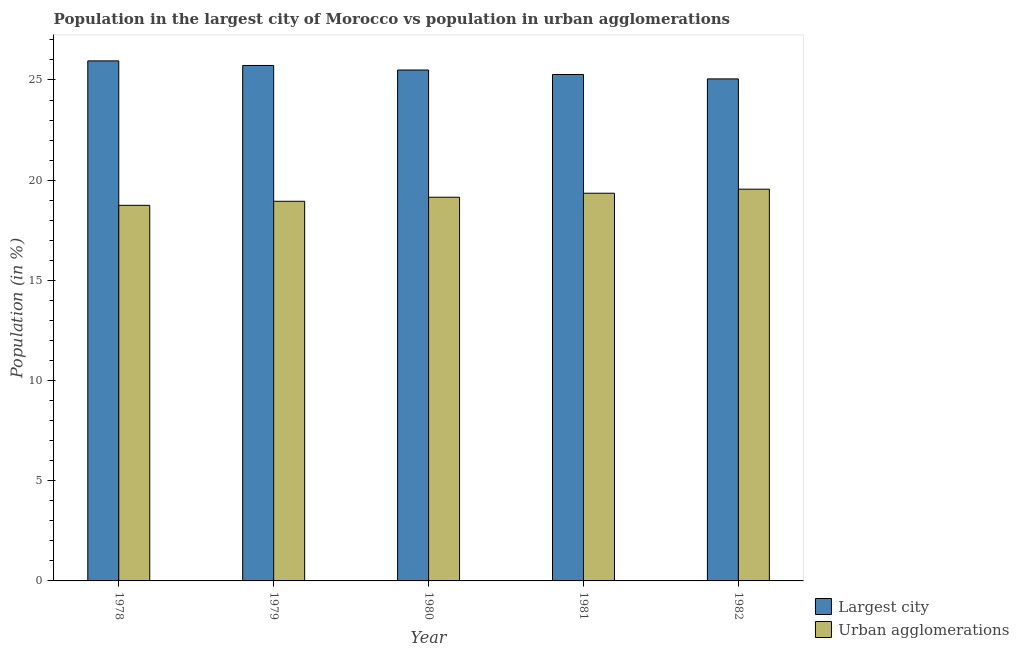How many different coloured bars are there?
Your response must be concise. 2. How many groups of bars are there?
Your response must be concise. 5. Are the number of bars per tick equal to the number of legend labels?
Your answer should be very brief. Yes. In how many cases, is the number of bars for a given year not equal to the number of legend labels?
Keep it short and to the point. 0. What is the population in urban agglomerations in 1980?
Keep it short and to the point. 19.15. Across all years, what is the maximum population in urban agglomerations?
Your answer should be very brief. 19.55. Across all years, what is the minimum population in the largest city?
Offer a terse response. 25.05. In which year was the population in the largest city maximum?
Offer a very short reply. 1978. In which year was the population in urban agglomerations minimum?
Offer a terse response. 1978. What is the total population in urban agglomerations in the graph?
Your answer should be compact. 95.74. What is the difference between the population in urban agglomerations in 1979 and that in 1982?
Your answer should be very brief. -0.6. What is the difference between the population in urban agglomerations in 1978 and the population in the largest city in 1980?
Your response must be concise. -0.4. What is the average population in the largest city per year?
Provide a short and direct response. 25.5. In how many years, is the population in the largest city greater than 17 %?
Keep it short and to the point. 5. What is the ratio of the population in urban agglomerations in 1979 to that in 1980?
Your response must be concise. 0.99. Is the difference between the population in the largest city in 1980 and 1981 greater than the difference between the population in urban agglomerations in 1980 and 1981?
Keep it short and to the point. No. What is the difference between the highest and the second highest population in urban agglomerations?
Your answer should be compact. 0.2. What is the difference between the highest and the lowest population in urban agglomerations?
Give a very brief answer. 0.81. Is the sum of the population in the largest city in 1978 and 1982 greater than the maximum population in urban agglomerations across all years?
Make the answer very short. Yes. What does the 2nd bar from the left in 1979 represents?
Make the answer very short. Urban agglomerations. What does the 2nd bar from the right in 1980 represents?
Provide a succinct answer. Largest city. How many bars are there?
Offer a very short reply. 10. Are all the bars in the graph horizontal?
Offer a terse response. No. How many years are there in the graph?
Give a very brief answer. 5. What is the difference between two consecutive major ticks on the Y-axis?
Provide a succinct answer. 5. Does the graph contain any zero values?
Offer a terse response. No. Does the graph contain grids?
Ensure brevity in your answer.  No. How are the legend labels stacked?
Keep it short and to the point. Vertical. What is the title of the graph?
Give a very brief answer. Population in the largest city of Morocco vs population in urban agglomerations. Does "Urban Population" appear as one of the legend labels in the graph?
Ensure brevity in your answer.  No. What is the label or title of the X-axis?
Your answer should be compact. Year. What is the label or title of the Y-axis?
Provide a short and direct response. Population (in %). What is the Population (in %) of Largest city in 1978?
Ensure brevity in your answer.  25.95. What is the Population (in %) of Urban agglomerations in 1978?
Offer a terse response. 18.74. What is the Population (in %) of Largest city in 1979?
Provide a short and direct response. 25.72. What is the Population (in %) in Urban agglomerations in 1979?
Your response must be concise. 18.95. What is the Population (in %) of Largest city in 1980?
Provide a short and direct response. 25.5. What is the Population (in %) in Urban agglomerations in 1980?
Give a very brief answer. 19.15. What is the Population (in %) of Largest city in 1981?
Your response must be concise. 25.27. What is the Population (in %) of Urban agglomerations in 1981?
Make the answer very short. 19.35. What is the Population (in %) in Largest city in 1982?
Ensure brevity in your answer.  25.05. What is the Population (in %) of Urban agglomerations in 1982?
Your answer should be compact. 19.55. Across all years, what is the maximum Population (in %) in Largest city?
Give a very brief answer. 25.95. Across all years, what is the maximum Population (in %) in Urban agglomerations?
Make the answer very short. 19.55. Across all years, what is the minimum Population (in %) of Largest city?
Provide a short and direct response. 25.05. Across all years, what is the minimum Population (in %) in Urban agglomerations?
Give a very brief answer. 18.74. What is the total Population (in %) in Largest city in the graph?
Your answer should be compact. 127.5. What is the total Population (in %) in Urban agglomerations in the graph?
Provide a succinct answer. 95.74. What is the difference between the Population (in %) in Largest city in 1978 and that in 1979?
Make the answer very short. 0.23. What is the difference between the Population (in %) of Urban agglomerations in 1978 and that in 1979?
Your response must be concise. -0.2. What is the difference between the Population (in %) in Largest city in 1978 and that in 1980?
Make the answer very short. 0.46. What is the difference between the Population (in %) in Urban agglomerations in 1978 and that in 1980?
Offer a very short reply. -0.4. What is the difference between the Population (in %) in Largest city in 1978 and that in 1981?
Your answer should be very brief. 0.68. What is the difference between the Population (in %) of Urban agglomerations in 1978 and that in 1981?
Your response must be concise. -0.6. What is the difference between the Population (in %) of Largest city in 1978 and that in 1982?
Provide a short and direct response. 0.9. What is the difference between the Population (in %) of Urban agglomerations in 1978 and that in 1982?
Make the answer very short. -0.81. What is the difference between the Population (in %) in Largest city in 1979 and that in 1980?
Your answer should be very brief. 0.23. What is the difference between the Population (in %) of Urban agglomerations in 1979 and that in 1980?
Keep it short and to the point. -0.2. What is the difference between the Population (in %) in Largest city in 1979 and that in 1981?
Make the answer very short. 0.45. What is the difference between the Population (in %) of Urban agglomerations in 1979 and that in 1981?
Ensure brevity in your answer.  -0.4. What is the difference between the Population (in %) in Largest city in 1979 and that in 1982?
Offer a terse response. 0.67. What is the difference between the Population (in %) of Urban agglomerations in 1979 and that in 1982?
Make the answer very short. -0.6. What is the difference between the Population (in %) of Largest city in 1980 and that in 1981?
Keep it short and to the point. 0.23. What is the difference between the Population (in %) of Urban agglomerations in 1980 and that in 1981?
Give a very brief answer. -0.2. What is the difference between the Population (in %) of Largest city in 1980 and that in 1982?
Make the answer very short. 0.44. What is the difference between the Population (in %) of Urban agglomerations in 1980 and that in 1982?
Keep it short and to the point. -0.4. What is the difference between the Population (in %) of Largest city in 1981 and that in 1982?
Offer a terse response. 0.22. What is the difference between the Population (in %) of Urban agglomerations in 1981 and that in 1982?
Keep it short and to the point. -0.2. What is the difference between the Population (in %) of Largest city in 1978 and the Population (in %) of Urban agglomerations in 1979?
Ensure brevity in your answer.  7.01. What is the difference between the Population (in %) of Largest city in 1978 and the Population (in %) of Urban agglomerations in 1980?
Your response must be concise. 6.8. What is the difference between the Population (in %) of Largest city in 1978 and the Population (in %) of Urban agglomerations in 1981?
Give a very brief answer. 6.6. What is the difference between the Population (in %) of Largest city in 1978 and the Population (in %) of Urban agglomerations in 1982?
Provide a short and direct response. 6.4. What is the difference between the Population (in %) of Largest city in 1979 and the Population (in %) of Urban agglomerations in 1980?
Your answer should be very brief. 6.58. What is the difference between the Population (in %) in Largest city in 1979 and the Population (in %) in Urban agglomerations in 1981?
Keep it short and to the point. 6.38. What is the difference between the Population (in %) in Largest city in 1979 and the Population (in %) in Urban agglomerations in 1982?
Offer a terse response. 6.17. What is the difference between the Population (in %) in Largest city in 1980 and the Population (in %) in Urban agglomerations in 1981?
Provide a short and direct response. 6.15. What is the difference between the Population (in %) of Largest city in 1980 and the Population (in %) of Urban agglomerations in 1982?
Give a very brief answer. 5.95. What is the difference between the Population (in %) of Largest city in 1981 and the Population (in %) of Urban agglomerations in 1982?
Provide a succinct answer. 5.72. What is the average Population (in %) of Largest city per year?
Your answer should be very brief. 25.5. What is the average Population (in %) of Urban agglomerations per year?
Provide a succinct answer. 19.15. In the year 1978, what is the difference between the Population (in %) in Largest city and Population (in %) in Urban agglomerations?
Offer a very short reply. 7.21. In the year 1979, what is the difference between the Population (in %) of Largest city and Population (in %) of Urban agglomerations?
Provide a succinct answer. 6.78. In the year 1980, what is the difference between the Population (in %) of Largest city and Population (in %) of Urban agglomerations?
Provide a succinct answer. 6.35. In the year 1981, what is the difference between the Population (in %) in Largest city and Population (in %) in Urban agglomerations?
Your answer should be very brief. 5.92. In the year 1982, what is the difference between the Population (in %) in Largest city and Population (in %) in Urban agglomerations?
Your response must be concise. 5.5. What is the ratio of the Population (in %) in Largest city in 1978 to that in 1979?
Keep it short and to the point. 1.01. What is the ratio of the Population (in %) in Urban agglomerations in 1978 to that in 1979?
Your response must be concise. 0.99. What is the ratio of the Population (in %) in Largest city in 1978 to that in 1980?
Your response must be concise. 1.02. What is the ratio of the Population (in %) in Urban agglomerations in 1978 to that in 1980?
Provide a short and direct response. 0.98. What is the ratio of the Population (in %) in Largest city in 1978 to that in 1981?
Give a very brief answer. 1.03. What is the ratio of the Population (in %) of Urban agglomerations in 1978 to that in 1981?
Provide a succinct answer. 0.97. What is the ratio of the Population (in %) of Largest city in 1978 to that in 1982?
Your answer should be very brief. 1.04. What is the ratio of the Population (in %) of Urban agglomerations in 1978 to that in 1982?
Your response must be concise. 0.96. What is the ratio of the Population (in %) in Largest city in 1979 to that in 1980?
Offer a very short reply. 1.01. What is the ratio of the Population (in %) of Largest city in 1979 to that in 1981?
Offer a terse response. 1.02. What is the ratio of the Population (in %) in Urban agglomerations in 1979 to that in 1981?
Offer a very short reply. 0.98. What is the ratio of the Population (in %) of Largest city in 1979 to that in 1982?
Ensure brevity in your answer.  1.03. What is the ratio of the Population (in %) in Urban agglomerations in 1979 to that in 1982?
Your answer should be very brief. 0.97. What is the ratio of the Population (in %) in Largest city in 1980 to that in 1981?
Make the answer very short. 1.01. What is the ratio of the Population (in %) of Urban agglomerations in 1980 to that in 1981?
Your response must be concise. 0.99. What is the ratio of the Population (in %) of Largest city in 1980 to that in 1982?
Keep it short and to the point. 1.02. What is the ratio of the Population (in %) of Urban agglomerations in 1980 to that in 1982?
Ensure brevity in your answer.  0.98. What is the ratio of the Population (in %) in Largest city in 1981 to that in 1982?
Your answer should be very brief. 1.01. What is the ratio of the Population (in %) in Urban agglomerations in 1981 to that in 1982?
Your response must be concise. 0.99. What is the difference between the highest and the second highest Population (in %) in Largest city?
Offer a terse response. 0.23. What is the difference between the highest and the second highest Population (in %) in Urban agglomerations?
Provide a short and direct response. 0.2. What is the difference between the highest and the lowest Population (in %) in Largest city?
Make the answer very short. 0.9. What is the difference between the highest and the lowest Population (in %) of Urban agglomerations?
Give a very brief answer. 0.81. 